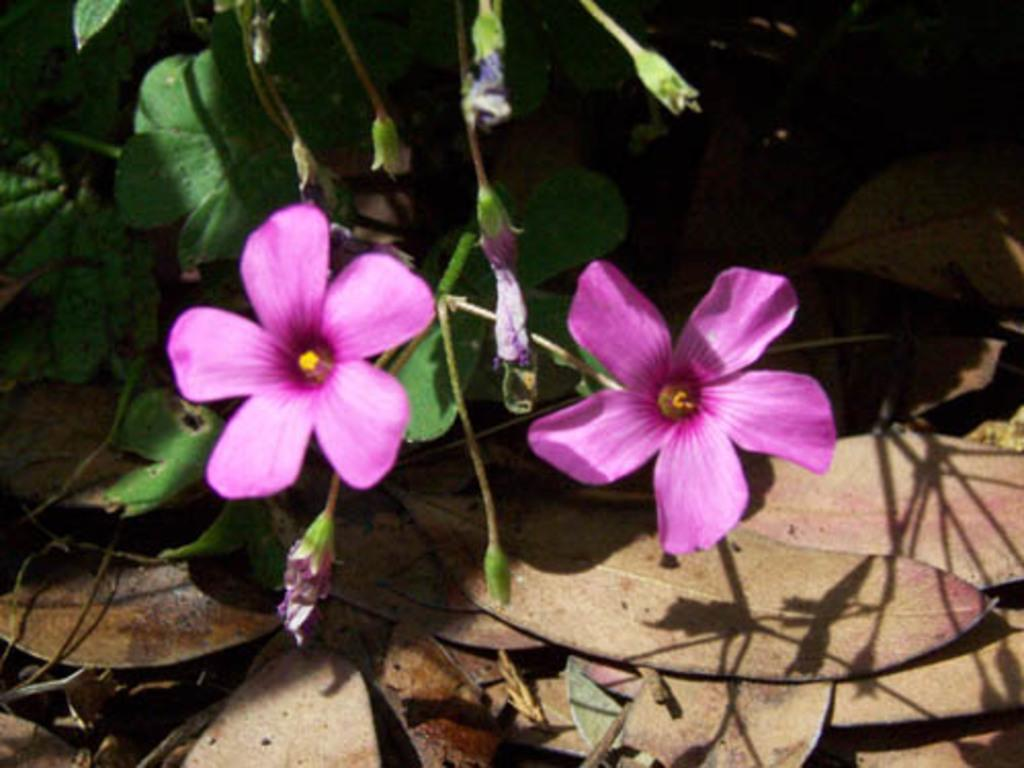What type of plant is visible in the image? There is a plant in the image, and it has flowers and buds. What is the condition of the plant's flowers? The flowers on the plant are visible in the image. What can be seen on the ground near the plant? There are dry leaves on the ground in the image. What type of education can be seen in the image? There is no reference to education in the image; it features a plant with flowers and buds, as well as dry leaves on the ground. How many ladybugs are present on the plant in the image? There are no ladybugs visible in the image; it only shows a plant with flowers and buds, along with dry leaves on the ground. 